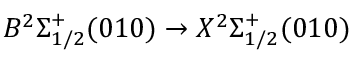Convert formula to latex. <formula><loc_0><loc_0><loc_500><loc_500>B ^ { 2 } \Sigma _ { 1 / 2 } ^ { + } ( 0 1 0 ) \rightarrow X ^ { 2 } \Sigma _ { 1 / 2 } ^ { + } ( 0 1 0 )</formula> 